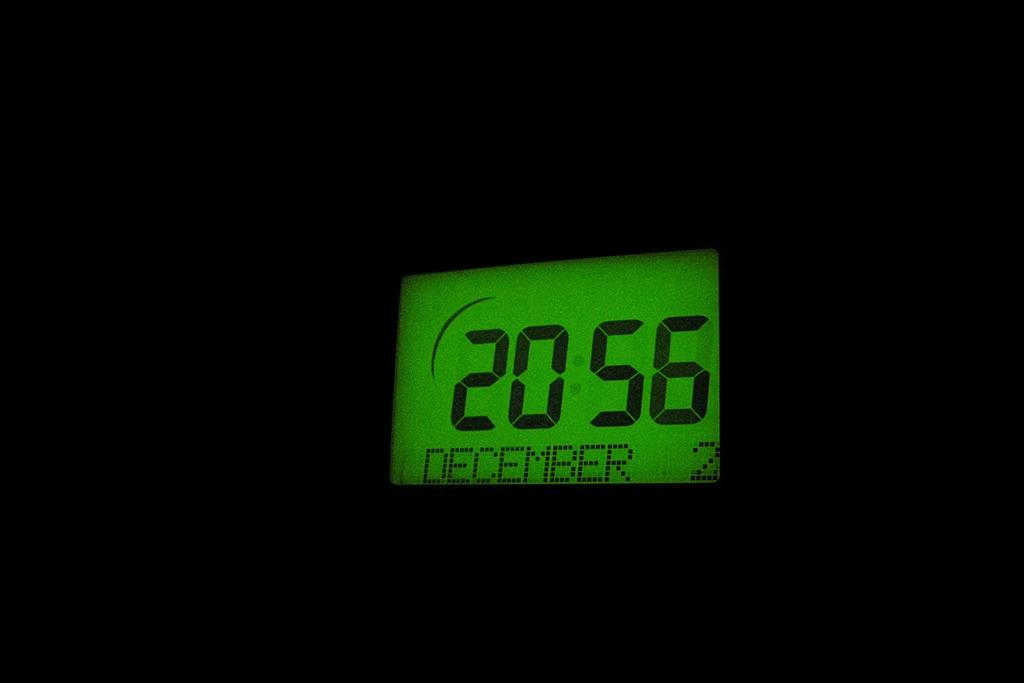<image>
Share a concise interpretation of the image provided. A digital clock showing the time is 20:56 on December 2. 